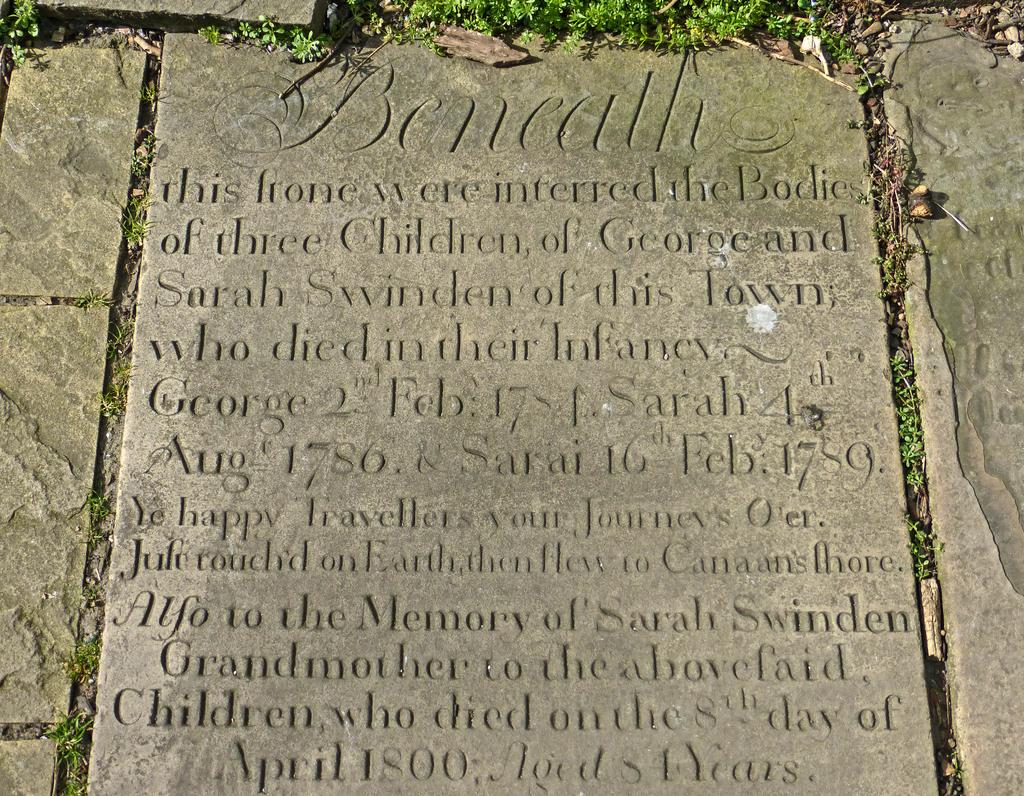What type of natural elements can be seen in the image? There are stones and grass in the image. Are there any man-made elements in the image? Yes, there is text written on one of the stones. Can you describe any numerical information present in the image? Yes, numerical numbers are present in the image. What type of structure is being built in the image? There is no structure being built in the image; it primarily features stones and grass. What fact is being presented in the image? The image does not present a specific fact; it contains stones, grass, text, and numerical numbers. 